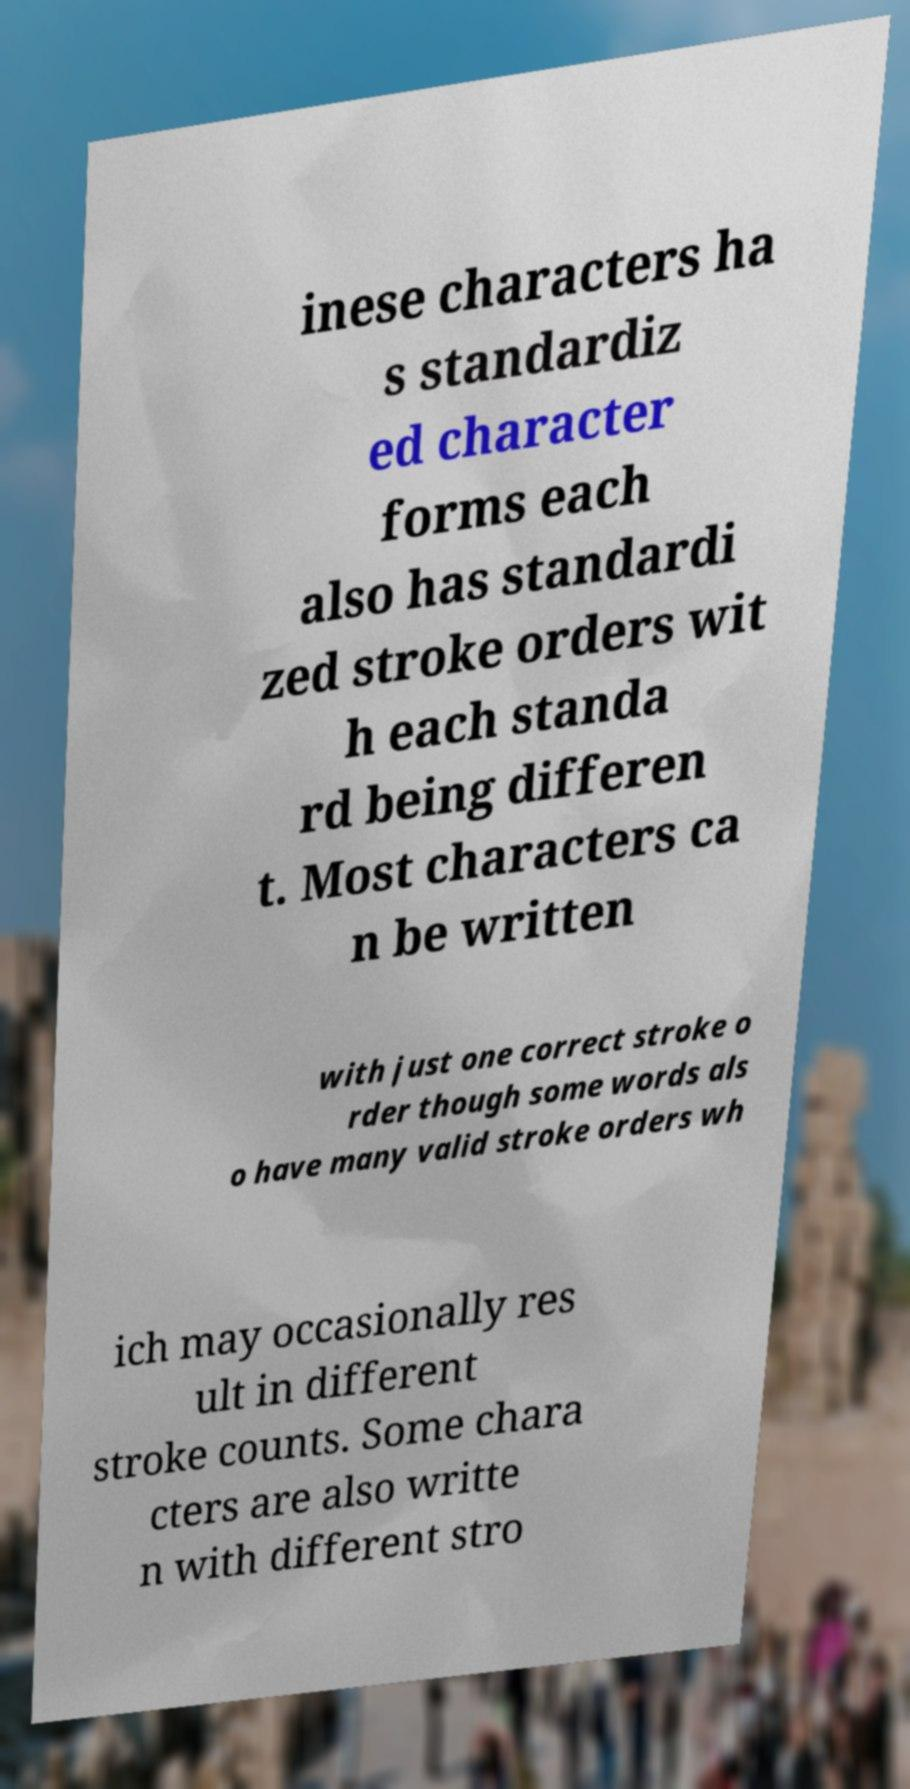Could you assist in decoding the text presented in this image and type it out clearly? inese characters ha s standardiz ed character forms each also has standardi zed stroke orders wit h each standa rd being differen t. Most characters ca n be written with just one correct stroke o rder though some words als o have many valid stroke orders wh ich may occasionally res ult in different stroke counts. Some chara cters are also writte n with different stro 